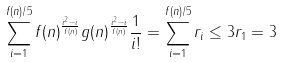<formula> <loc_0><loc_0><loc_500><loc_500>\ \sum _ { i = 1 } ^ { f ( n ) / 5 } f ( n ) ^ { \frac { i ^ { 2 } - i } { f ( n ) } } g ( n ) ^ { \frac { i ^ { 2 } - i } { f ( n ) } } \frac { 1 } { i ! } = \sum _ { i = 1 } ^ { f ( n ) / 5 } r _ { i } \leq 3 r _ { 1 } = 3</formula> 